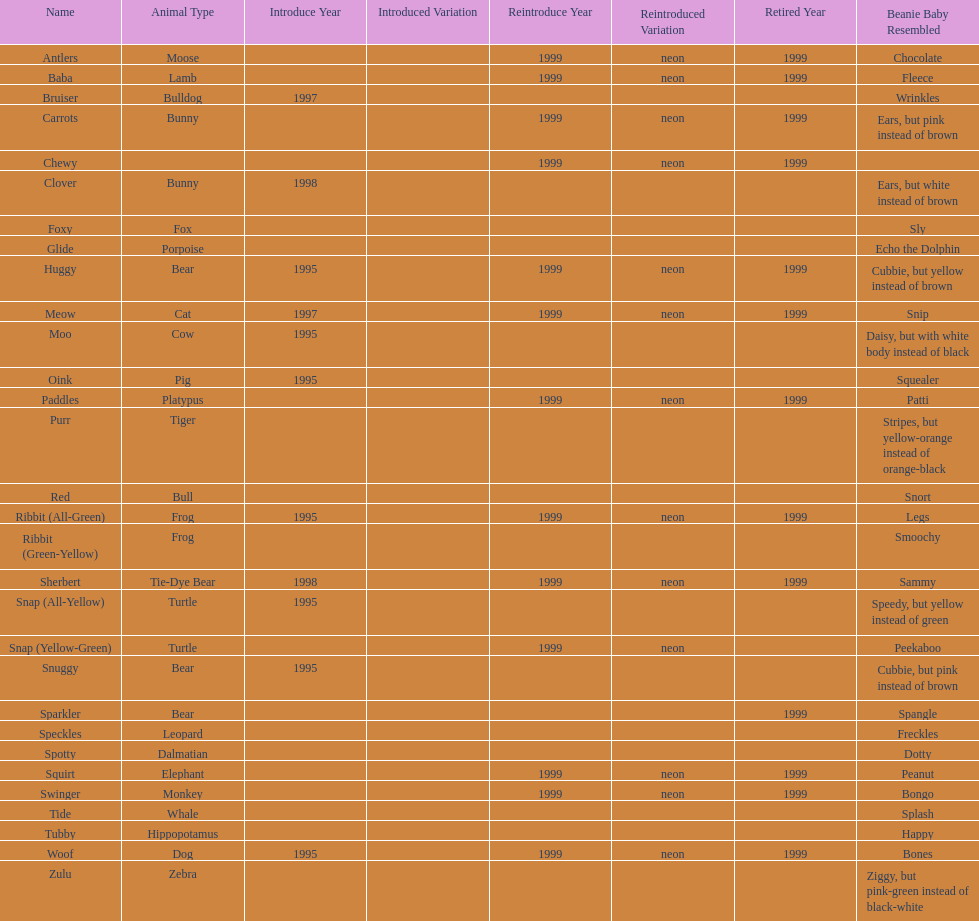Tell me the number of pillow pals reintroduced in 1999. 13. 